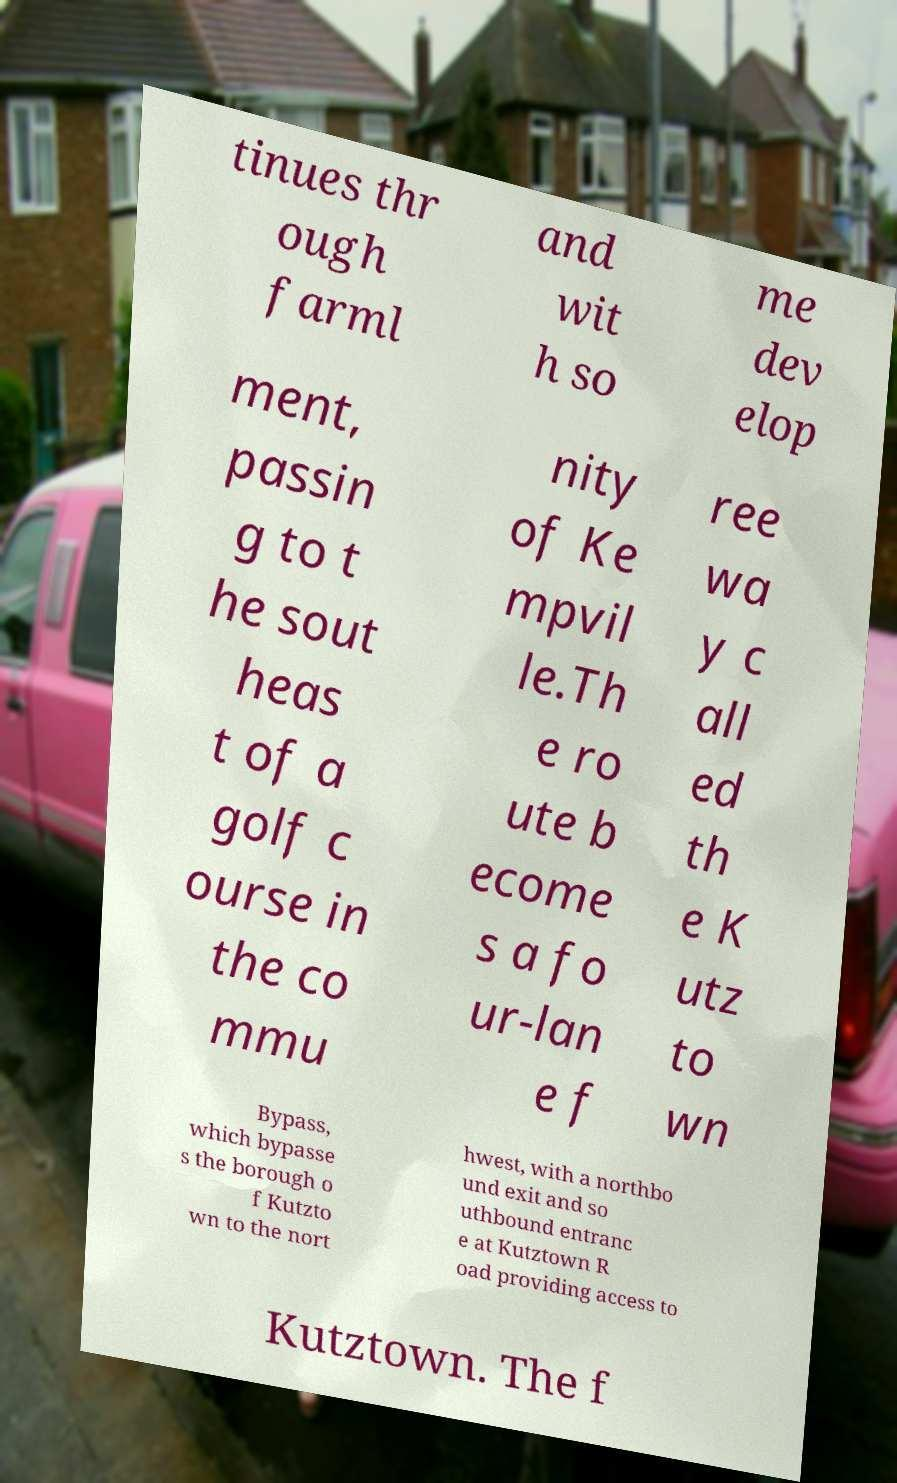Could you extract and type out the text from this image? tinues thr ough farml and wit h so me dev elop ment, passin g to t he sout heas t of a golf c ourse in the co mmu nity of Ke mpvil le.Th e ro ute b ecome s a fo ur-lan e f ree wa y c all ed th e K utz to wn Bypass, which bypasse s the borough o f Kutzto wn to the nort hwest, with a northbo und exit and so uthbound entranc e at Kutztown R oad providing access to Kutztown. The f 